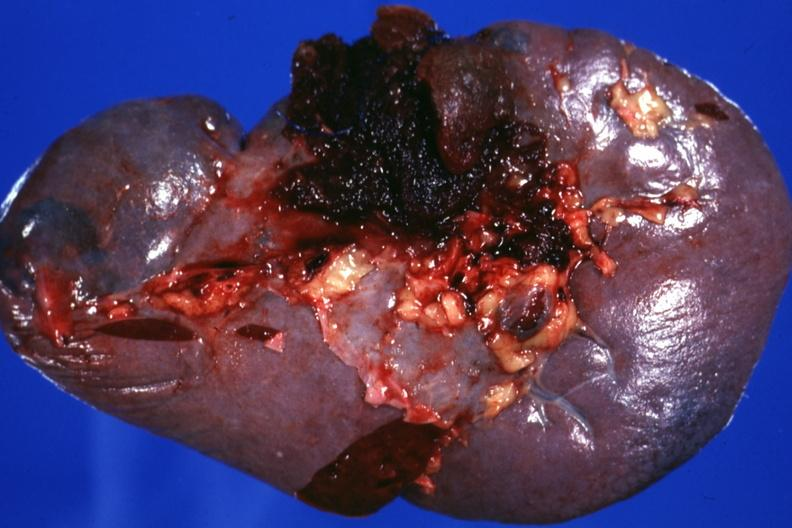what is present?
Answer the question using a single word or phrase. Traumatic rupture 